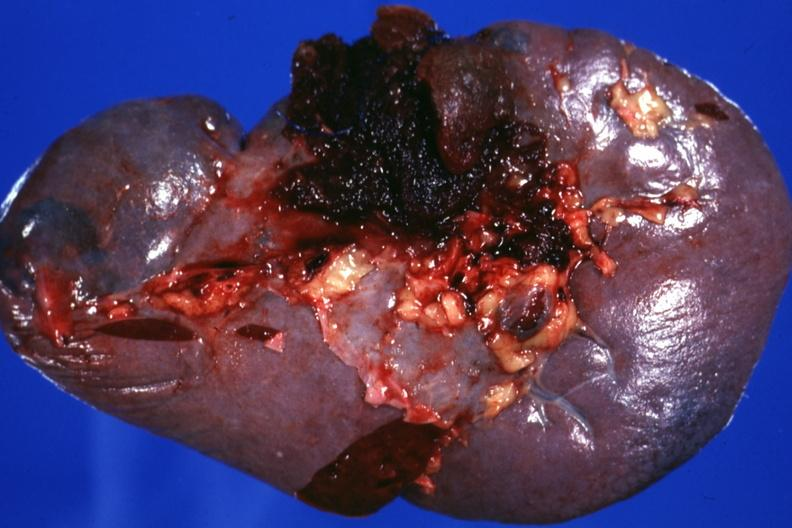what is present?
Answer the question using a single word or phrase. Traumatic rupture 